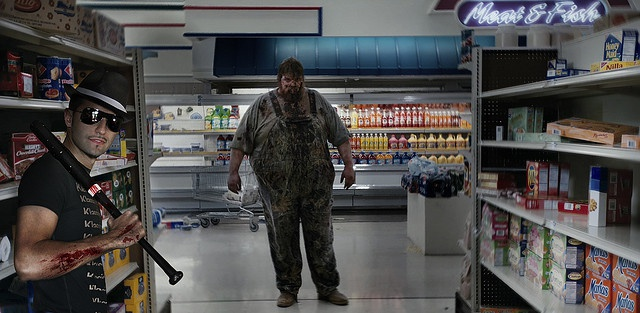Describe the objects in this image and their specific colors. I can see people in black and gray tones, people in black, gray, and maroon tones, baseball bat in black, gray, lightgray, and darkgray tones, bottle in black, maroon, brown, gray, and darkgray tones, and bottle in black, maroon, brown, and gray tones in this image. 